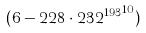Convert formula to latex. <formula><loc_0><loc_0><loc_500><loc_500>( 6 - 2 2 8 \cdot { 2 3 2 ^ { 1 9 3 } } ^ { 1 0 } )</formula> 